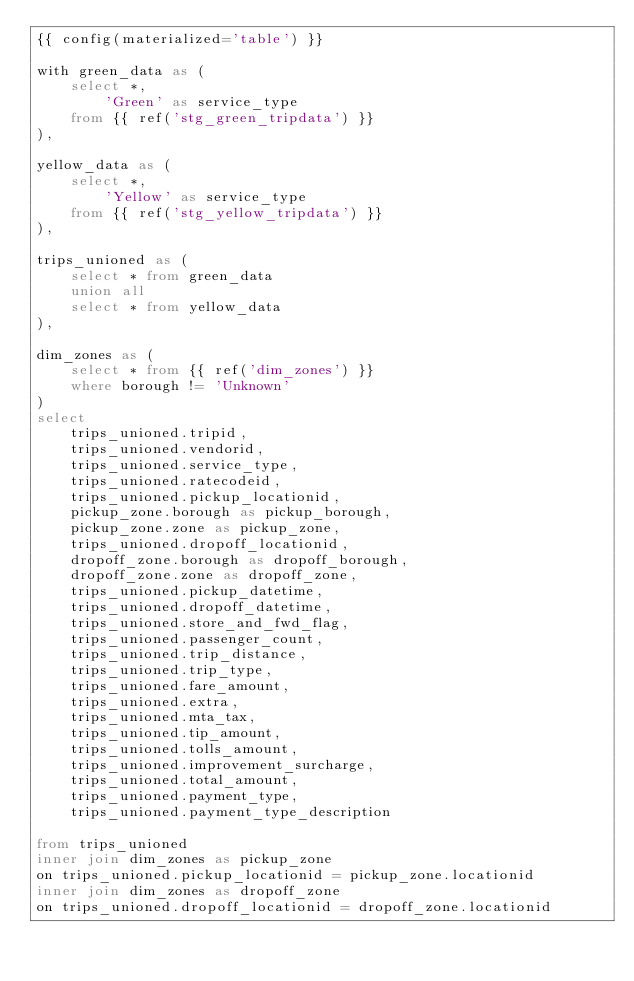Convert code to text. <code><loc_0><loc_0><loc_500><loc_500><_SQL_>{{ config(materialized='table') }}

with green_data as (
    select *, 
        'Green' as service_type 
    from {{ ref('stg_green_tripdata') }}
), 

yellow_data as (
    select *, 
        'Yellow' as service_type
    from {{ ref('stg_yellow_tripdata') }}
), 

trips_unioned as (
    select * from green_data
    union all
    select * from yellow_data
), 

dim_zones as (
    select * from {{ ref('dim_zones') }}
    where borough != 'Unknown'
)
select 
    trips_unioned.tripid, 
    trips_unioned.vendorid, 
    trips_unioned.service_type,
    trips_unioned.ratecodeid, 
    trips_unioned.pickup_locationid, 
    pickup_zone.borough as pickup_borough, 
    pickup_zone.zone as pickup_zone, 
    trips_unioned.dropoff_locationid,
    dropoff_zone.borough as dropoff_borough, 
    dropoff_zone.zone as dropoff_zone,  
    trips_unioned.pickup_datetime, 
    trips_unioned.dropoff_datetime, 
    trips_unioned.store_and_fwd_flag, 
    trips_unioned.passenger_count, 
    trips_unioned.trip_distance, 
    trips_unioned.trip_type, 
    trips_unioned.fare_amount, 
    trips_unioned.extra, 
    trips_unioned.mta_tax, 
    trips_unioned.tip_amount, 
    trips_unioned.tolls_amount, 
    trips_unioned.improvement_surcharge, 
    trips_unioned.total_amount, 
    trips_unioned.payment_type, 
    trips_unioned.payment_type_description

from trips_unioned
inner join dim_zones as pickup_zone
on trips_unioned.pickup_locationid = pickup_zone.locationid
inner join dim_zones as dropoff_zone
on trips_unioned.dropoff_locationid = dropoff_zone.locationid</code> 